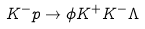Convert formula to latex. <formula><loc_0><loc_0><loc_500><loc_500>K ^ { - } p \to \phi K ^ { + } K ^ { - } \Lambda</formula> 